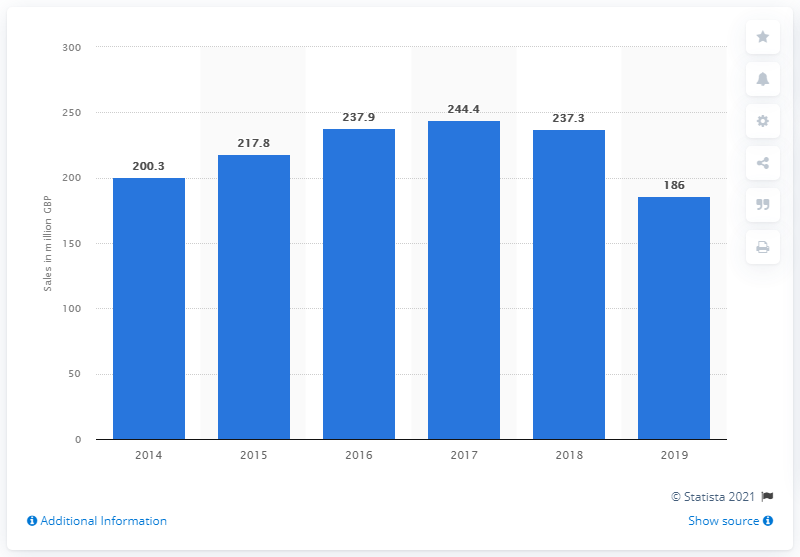Draw attention to some important aspects in this diagram. The total sales of Ernest Jones for the 2019 fiscal year were 186... 